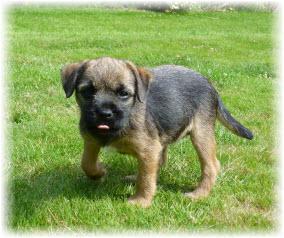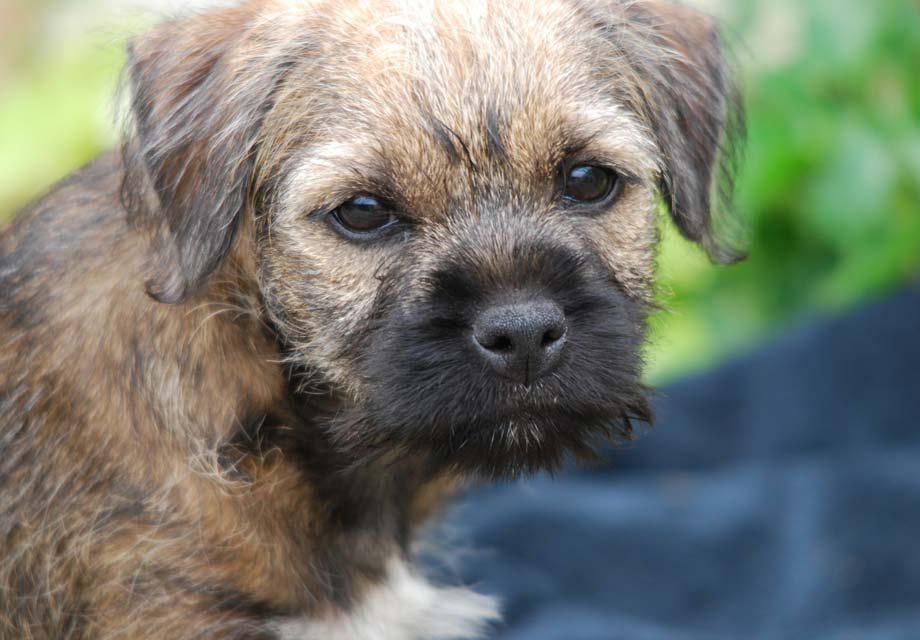The first image is the image on the left, the second image is the image on the right. Assess this claim about the two images: "The dog in the image on the left has only three feet on the ground.". Correct or not? Answer yes or no. Yes. 